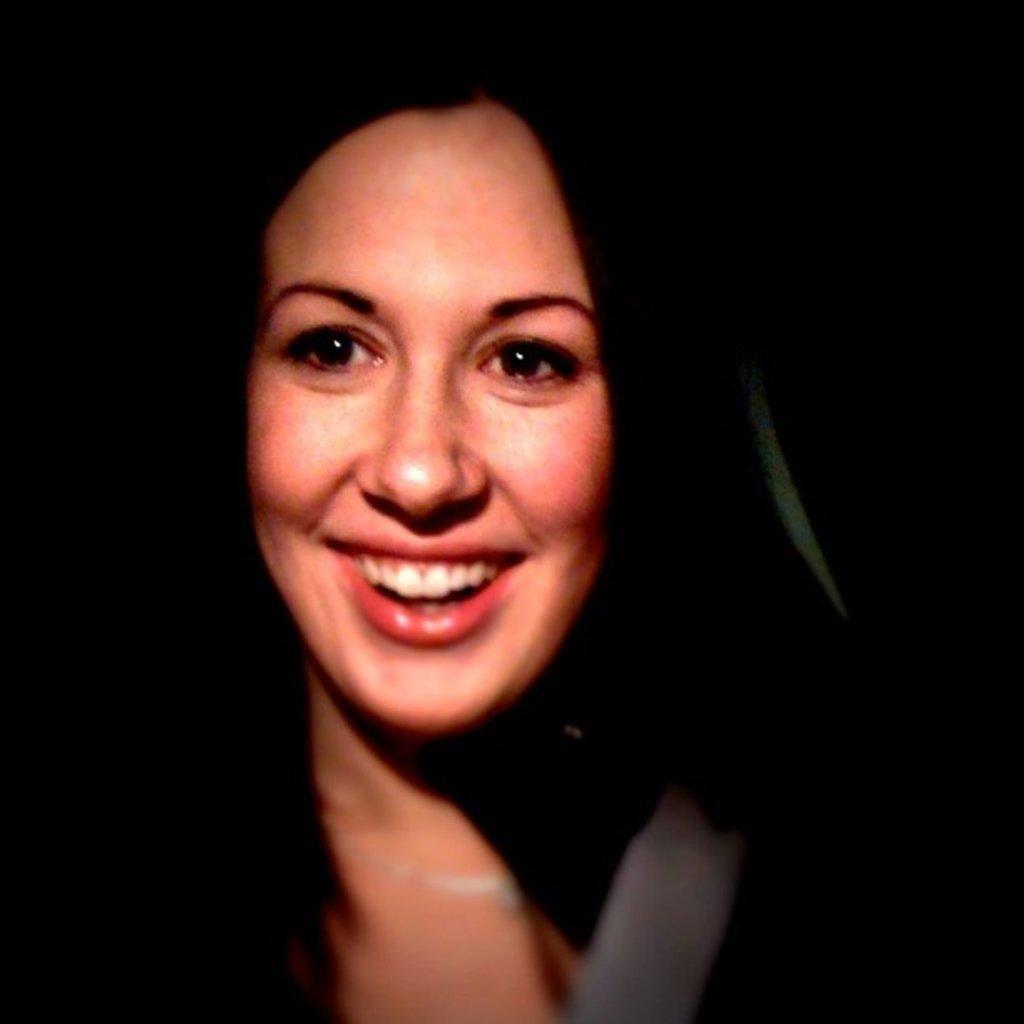Could you give a brief overview of what you see in this image? In this picture there is a woman. The picture has blurred edges. The background is dark. 